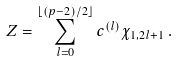Convert formula to latex. <formula><loc_0><loc_0><loc_500><loc_500>Z = \sum _ { l = 0 } ^ { \lfloor ( p - 2 ) / 2 \rfloor } c ^ { ( l ) } \chi _ { 1 , 2 l + 1 } \, .</formula> 